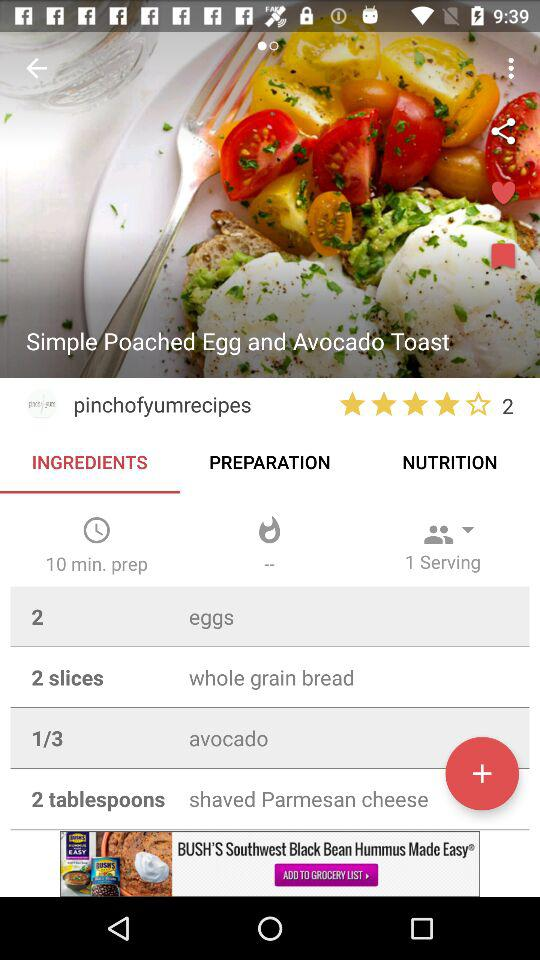How many servings does this recipe make?
Answer the question using a single word or phrase. 1 